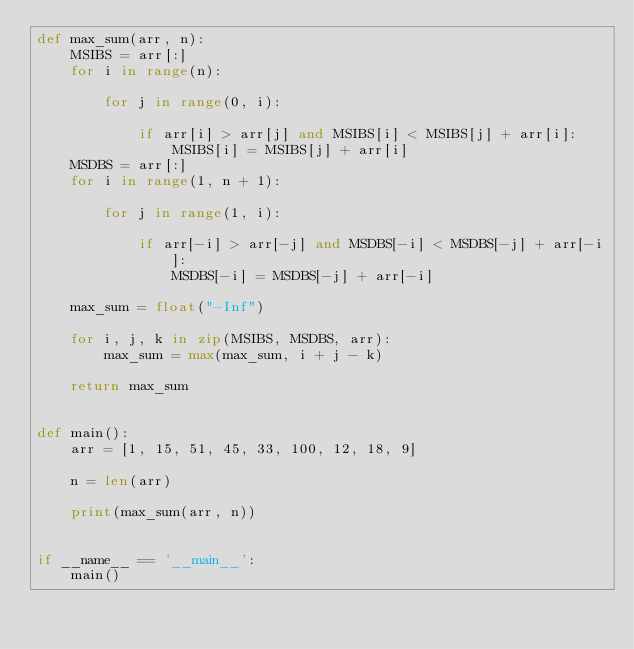Convert code to text. <code><loc_0><loc_0><loc_500><loc_500><_Python_>def max_sum(arr, n):
    MSIBS = arr[:]
    for i in range(n):

        for j in range(0, i):

            if arr[i] > arr[j] and MSIBS[i] < MSIBS[j] + arr[i]:
                MSIBS[i] = MSIBS[j] + arr[i]
    MSDBS = arr[:]
    for i in range(1, n + 1):

        for j in range(1, i):

            if arr[-i] > arr[-j] and MSDBS[-i] < MSDBS[-j] + arr[-i]:
                MSDBS[-i] = MSDBS[-j] + arr[-i]

    max_sum = float("-Inf")

    for i, j, k in zip(MSIBS, MSDBS, arr):
        max_sum = max(max_sum, i + j - k)

    return max_sum


def main():
    arr = [1, 15, 51, 45, 33, 100, 12, 18, 9]

    n = len(arr)

    print(max_sum(arr, n))


if __name__ == '__main__':
    main()
</code> 